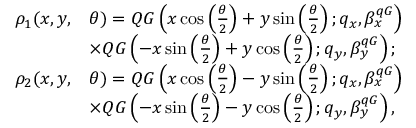Convert formula to latex. <formula><loc_0><loc_0><loc_500><loc_500>\begin{array} { r l } { \rho _ { 1 } ( x , y , } & { \theta ) = Q G \left ( x \cos \left ( \frac { \theta } { 2 } \right ) + y \sin \left ( \frac { \theta } { 2 } \right ) ; q _ { x } , \beta _ { x } ^ { q G } \right ) } \\ & { \times Q G \left ( - x \sin \left ( \frac { \theta } { 2 } \right ) + y \cos \left ( \frac { \theta } { 2 } \right ) ; q _ { y } , \beta _ { y } ^ { q G } \right ) ; } \\ { \rho _ { 2 } ( x , y , } & { \theta ) = Q G \left ( x \cos \left ( \frac { \theta } { 2 } \right ) - y \sin \left ( \frac { \theta } { 2 } \right ) ; q _ { x } , \beta _ { x } ^ { q G } \right ) } \\ & { \times Q G \left ( - x \sin \left ( \frac { \theta } { 2 } \right ) - y \cos \left ( \frac { \theta } { 2 } \right ) ; q _ { y } , \beta _ { y } ^ { q G } \right ) , } \end{array}</formula> 